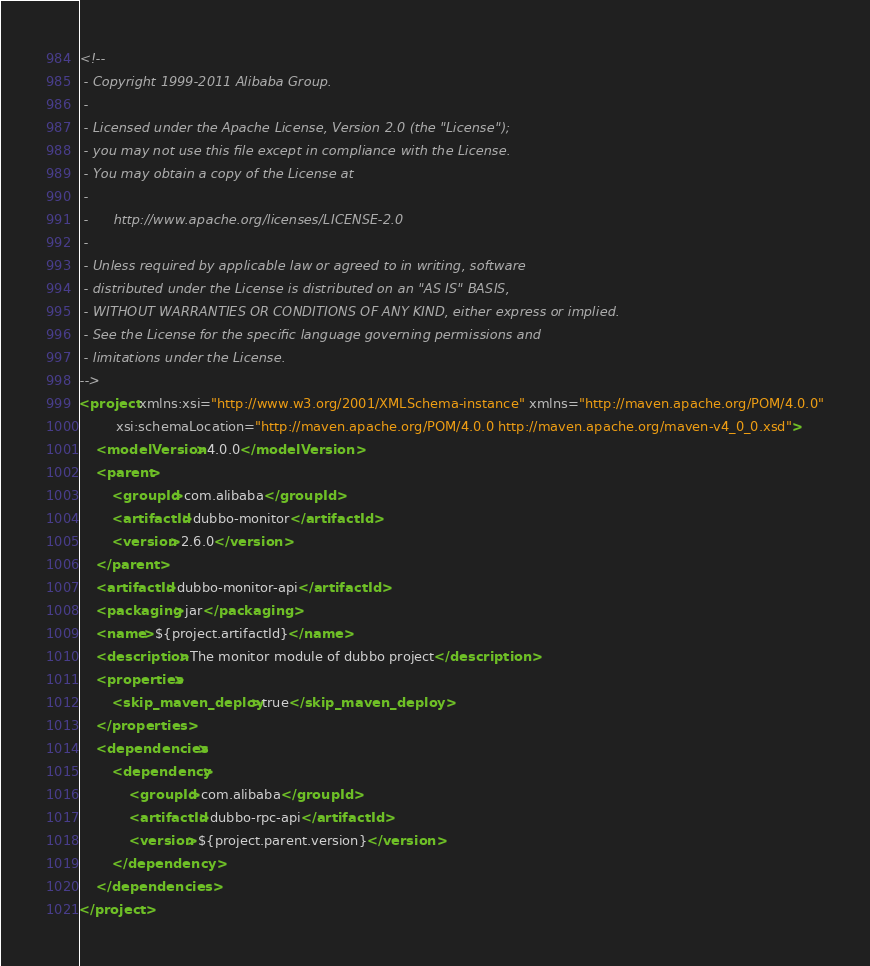Convert code to text. <code><loc_0><loc_0><loc_500><loc_500><_XML_><!--
 - Copyright 1999-2011 Alibaba Group.
 -  
 - Licensed under the Apache License, Version 2.0 (the "License");
 - you may not use this file except in compliance with the License.
 - You may obtain a copy of the License at
 -  
 -      http://www.apache.org/licenses/LICENSE-2.0
 -  
 - Unless required by applicable law or agreed to in writing, software
 - distributed under the License is distributed on an "AS IS" BASIS,
 - WITHOUT WARRANTIES OR CONDITIONS OF ANY KIND, either express or implied.
 - See the License for the specific language governing permissions and
 - limitations under the License.
-->
<project xmlns:xsi="http://www.w3.org/2001/XMLSchema-instance" xmlns="http://maven.apache.org/POM/4.0.0"
         xsi:schemaLocation="http://maven.apache.org/POM/4.0.0 http://maven.apache.org/maven-v4_0_0.xsd">
    <modelVersion>4.0.0</modelVersion>
    <parent>
        <groupId>com.alibaba</groupId>
        <artifactId>dubbo-monitor</artifactId>
        <version>2.6.0</version>
    </parent>
    <artifactId>dubbo-monitor-api</artifactId>
    <packaging>jar</packaging>
    <name>${project.artifactId}</name>
    <description>The monitor module of dubbo project</description>
    <properties>
        <skip_maven_deploy>true</skip_maven_deploy>
    </properties>
    <dependencies>
        <dependency>
            <groupId>com.alibaba</groupId>
            <artifactId>dubbo-rpc-api</artifactId>
            <version>${project.parent.version}</version>
        </dependency>
    </dependencies>
</project></code> 